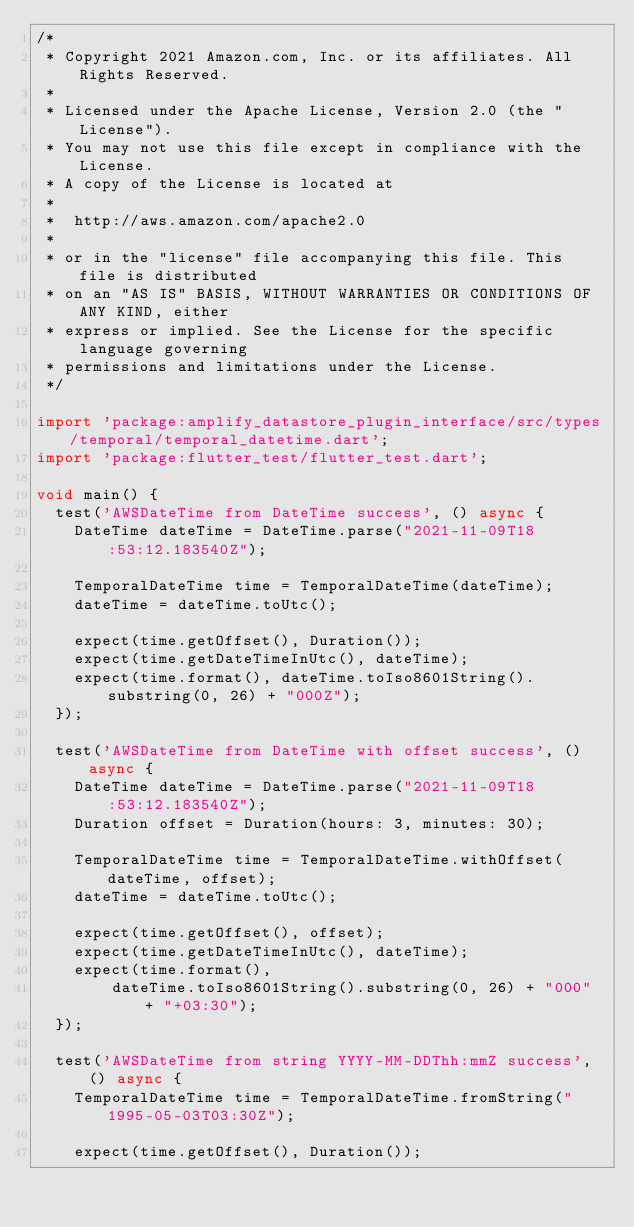Convert code to text. <code><loc_0><loc_0><loc_500><loc_500><_Dart_>/*
 * Copyright 2021 Amazon.com, Inc. or its affiliates. All Rights Reserved.
 *
 * Licensed under the Apache License, Version 2.0 (the "License").
 * You may not use this file except in compliance with the License.
 * A copy of the License is located at
 *
 *  http://aws.amazon.com/apache2.0
 *
 * or in the "license" file accompanying this file. This file is distributed
 * on an "AS IS" BASIS, WITHOUT WARRANTIES OR CONDITIONS OF ANY KIND, either
 * express or implied. See the License for the specific language governing
 * permissions and limitations under the License.
 */

import 'package:amplify_datastore_plugin_interface/src/types/temporal/temporal_datetime.dart';
import 'package:flutter_test/flutter_test.dart';

void main() {
  test('AWSDateTime from DateTime success', () async {
    DateTime dateTime = DateTime.parse("2021-11-09T18:53:12.183540Z");

    TemporalDateTime time = TemporalDateTime(dateTime);
    dateTime = dateTime.toUtc();

    expect(time.getOffset(), Duration());
    expect(time.getDateTimeInUtc(), dateTime);
    expect(time.format(), dateTime.toIso8601String().substring(0, 26) + "000Z");
  });

  test('AWSDateTime from DateTime with offset success', () async {
    DateTime dateTime = DateTime.parse("2021-11-09T18:53:12.183540Z");
    Duration offset = Duration(hours: 3, minutes: 30);

    TemporalDateTime time = TemporalDateTime.withOffset(dateTime, offset);
    dateTime = dateTime.toUtc();

    expect(time.getOffset(), offset);
    expect(time.getDateTimeInUtc(), dateTime);
    expect(time.format(),
        dateTime.toIso8601String().substring(0, 26) + "000" + "+03:30");
  });

  test('AWSDateTime from string YYYY-MM-DDThh:mmZ success', () async {
    TemporalDateTime time = TemporalDateTime.fromString("1995-05-03T03:30Z");

    expect(time.getOffset(), Duration());</code> 